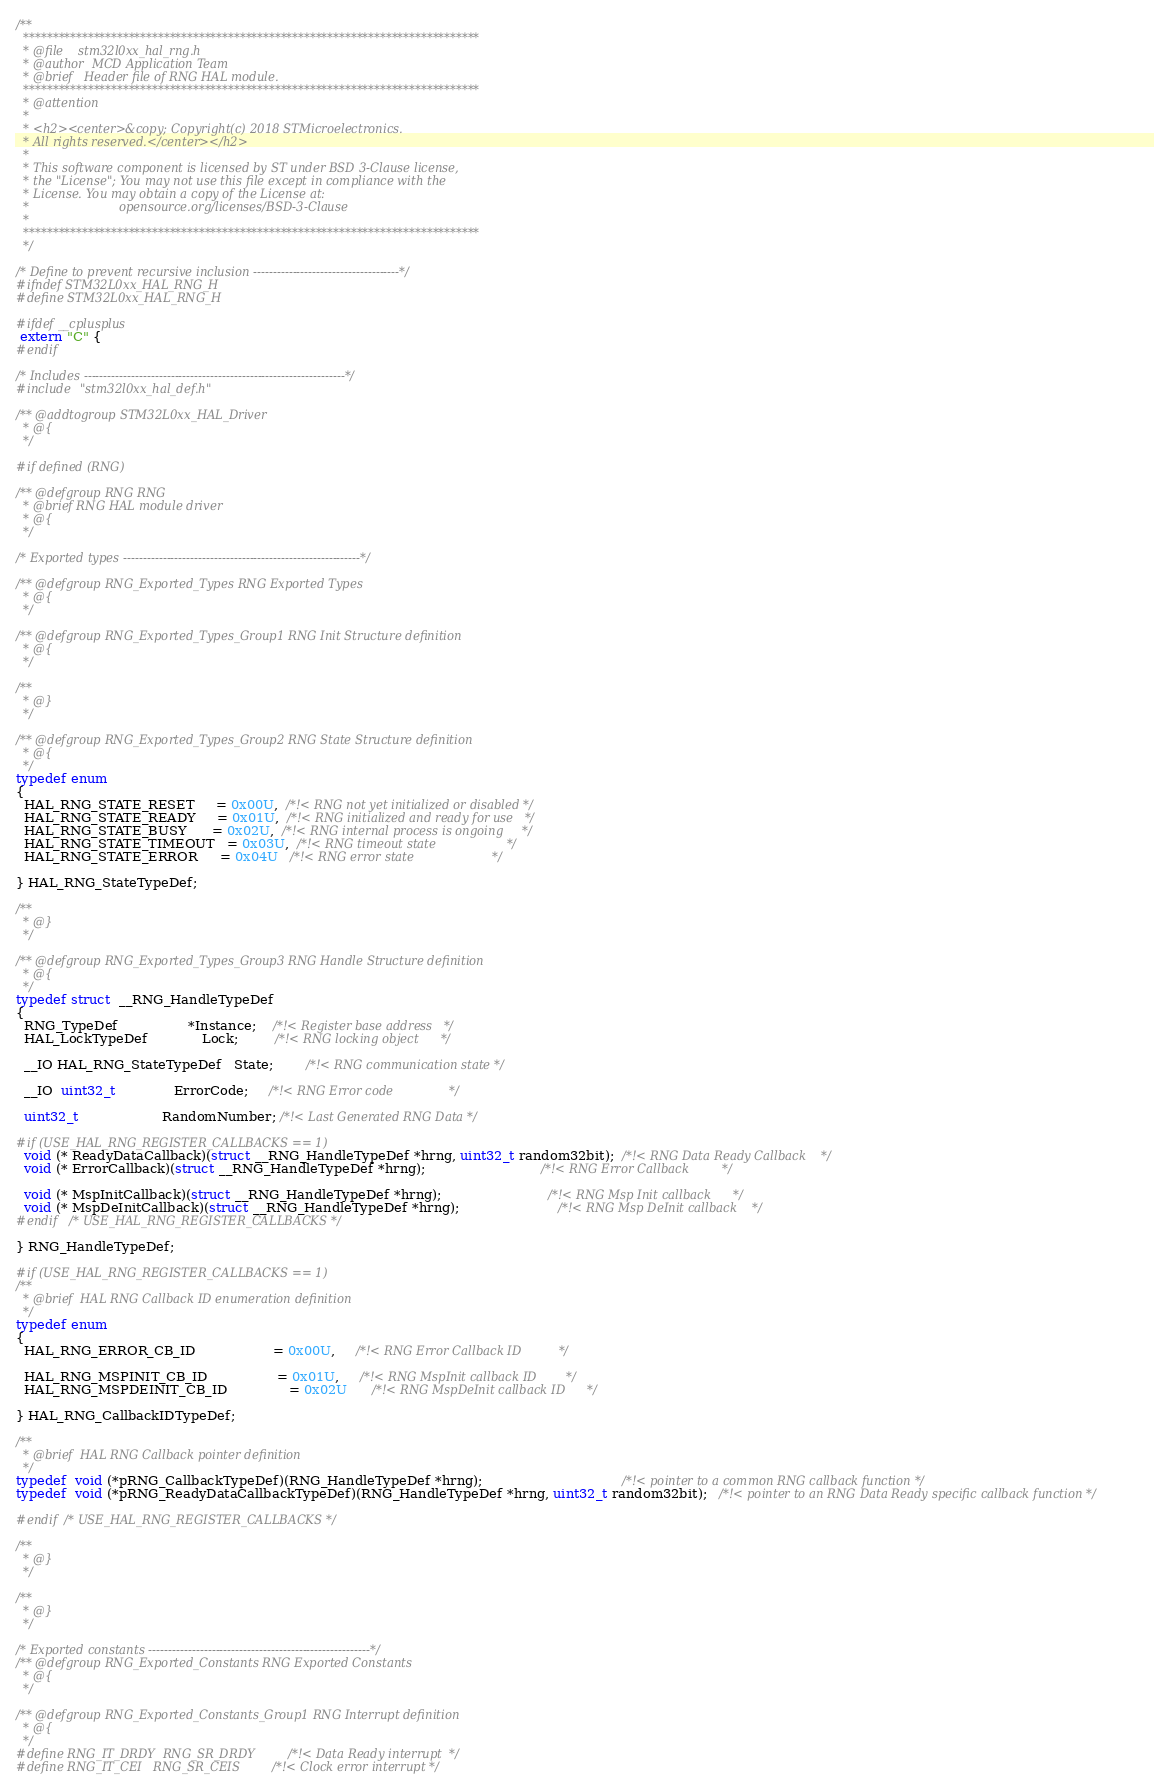<code> <loc_0><loc_0><loc_500><loc_500><_C_>/**
  ******************************************************************************
  * @file    stm32l0xx_hal_rng.h
  * @author  MCD Application Team
  * @brief   Header file of RNG HAL module.
  ******************************************************************************
  * @attention
  *
  * <h2><center>&copy; Copyright(c) 2018 STMicroelectronics.
  * All rights reserved.</center></h2>
  *
  * This software component is licensed by ST under BSD 3-Clause license,
  * the "License"; You may not use this file except in compliance with the
  * License. You may obtain a copy of the License at:
  *                        opensource.org/licenses/BSD-3-Clause
  *
  ******************************************************************************
  */

/* Define to prevent recursive inclusion -------------------------------------*/
#ifndef STM32L0xx_HAL_RNG_H
#define STM32L0xx_HAL_RNG_H

#ifdef __cplusplus
 extern "C" {
#endif

/* Includes ------------------------------------------------------------------*/
#include "stm32l0xx_hal_def.h"

/** @addtogroup STM32L0xx_HAL_Driver
  * @{
  */

#if defined (RNG)

/** @defgroup RNG RNG
  * @brief RNG HAL module driver
  * @{
  */

/* Exported types ------------------------------------------------------------*/

/** @defgroup RNG_Exported_Types RNG Exported Types
  * @{
  */

/** @defgroup RNG_Exported_Types_Group1 RNG Init Structure definition
  * @{
  */

/**
  * @}
  */

/** @defgroup RNG_Exported_Types_Group2 RNG State Structure definition
  * @{
  */
typedef enum
{
  HAL_RNG_STATE_RESET     = 0x00U,  /*!< RNG not yet initialized or disabled */
  HAL_RNG_STATE_READY     = 0x01U,  /*!< RNG initialized and ready for use   */
  HAL_RNG_STATE_BUSY      = 0x02U,  /*!< RNG internal process is ongoing     */
  HAL_RNG_STATE_TIMEOUT   = 0x03U,  /*!< RNG timeout state                   */
  HAL_RNG_STATE_ERROR     = 0x04U   /*!< RNG error state                     */

} HAL_RNG_StateTypeDef;

/**
  * @}
  */

/** @defgroup RNG_Exported_Types_Group3 RNG Handle Structure definition
  * @{
  */
typedef struct  __RNG_HandleTypeDef
{
  RNG_TypeDef                 *Instance;    /*!< Register base address   */
  HAL_LockTypeDef             Lock;         /*!< RNG locking object      */

  __IO HAL_RNG_StateTypeDef   State;        /*!< RNG communication state */

  __IO  uint32_t              ErrorCode;     /*!< RNG Error code               */

  uint32_t                    RandomNumber; /*!< Last Generated RNG Data */

#if (USE_HAL_RNG_REGISTER_CALLBACKS == 1)
  void (* ReadyDataCallback)(struct __RNG_HandleTypeDef *hrng, uint32_t random32bit);  /*!< RNG Data Ready Callback    */
  void (* ErrorCallback)(struct __RNG_HandleTypeDef *hrng);                            /*!< RNG Error Callback         */

  void (* MspInitCallback)(struct __RNG_HandleTypeDef *hrng);                          /*!< RNG Msp Init callback      */
  void (* MspDeInitCallback)(struct __RNG_HandleTypeDef *hrng);                        /*!< RNG Msp DeInit callback    */
#endif  /* USE_HAL_RNG_REGISTER_CALLBACKS */

} RNG_HandleTypeDef;

#if (USE_HAL_RNG_REGISTER_CALLBACKS == 1)
/**
  * @brief  HAL RNG Callback ID enumeration definition
  */
typedef enum
{
  HAL_RNG_ERROR_CB_ID                   = 0x00U,     /*!< RNG Error Callback ID          */

  HAL_RNG_MSPINIT_CB_ID                 = 0x01U,     /*!< RNG MspInit callback ID        */
  HAL_RNG_MSPDEINIT_CB_ID               = 0x02U      /*!< RNG MspDeInit callback ID      */

} HAL_RNG_CallbackIDTypeDef;

/**
  * @brief  HAL RNG Callback pointer definition
  */
typedef  void (*pRNG_CallbackTypeDef)(RNG_HandleTypeDef *hrng);                                  /*!< pointer to a common RNG callback function */
typedef  void (*pRNG_ReadyDataCallbackTypeDef)(RNG_HandleTypeDef *hrng, uint32_t random32bit);   /*!< pointer to an RNG Data Ready specific callback function */

#endif /* USE_HAL_RNG_REGISTER_CALLBACKS */

/**
  * @}
  */

/**
  * @}
  */

/* Exported constants --------------------------------------------------------*/
/** @defgroup RNG_Exported_Constants RNG Exported Constants
  * @{
  */

/** @defgroup RNG_Exported_Constants_Group1 RNG Interrupt definition
  * @{
  */
#define RNG_IT_DRDY  RNG_SR_DRDY  /*!< Data Ready interrupt  */
#define RNG_IT_CEI   RNG_SR_CEIS  /*!< Clock error interrupt */</code> 